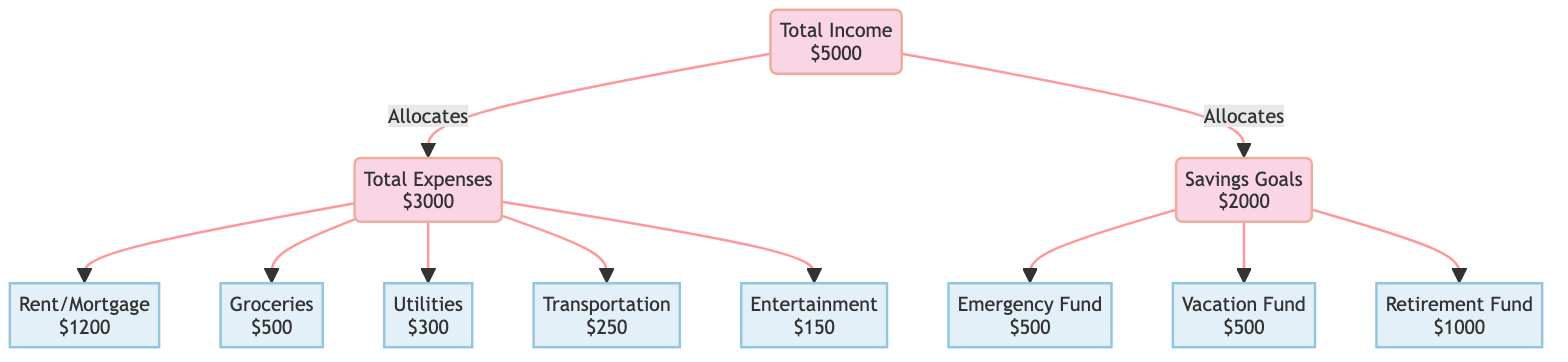What is the total income depicted in the diagram? The total income is clearly labeled in the diagram as "$5000". This is a direct reading from the "Total Income" node.
Answer: $5000 How much is allocated to rent/mortgage? The diagram indicates that "$1200" is specifically allocated to rent/mortgage under the expenses category, which can be found in the "Rent/Mortgage" node.
Answer: $1200 What is the combined amount allocated for groceries and utilities? Groceries are allocated "$500" and utilities are allocated "$300". Adding those together: $500 + $300 gives $800, which accounts for both categories under expenses.
Answer: $800 How many categories of expenses are outlined in the diagram? The diagram shows the following expense categories: Rent, Groceries, Utilities, Transport, and Entertainment. Counting each of these, we find there are five categories of expenses.
Answer: 5 What percentage of the total income is allocated to savings goals? The savings amount is "$2000", which is a portion of the total income "$5000". To find the percentage, divide $2000 by $5000 and multiply by 100. This results in a calculation of (2000/5000) x 100 = 40%.
Answer: 40% Which savings goal has the highest allocation? The diagram shows three savings goals: Emergency Fund ($500), Vacation Fund ($500), and Retirement Fund ($1000). The Retirement Fund has the highest amount allocated, which is "$1000".
Answer: Retirement Fund How much is spent on entertainment? The diagram specifies that "$150" is allocated to entertainment under the total expenses. This is found in the "Entertainment" node.
Answer: $150 What is the total amount allocated to savings? Looking at the savings section in the diagram, we see the total savings goals are "$2000", which is directly stated in the "Savings Goals" node.
Answer: $2000 What is the difference between total income and total expenses? The total income is "$5000" and total expenses are "$3000". To find the difference, we subtract the expenses from the income: $5000 - $3000 = $2000.
Answer: $2000 